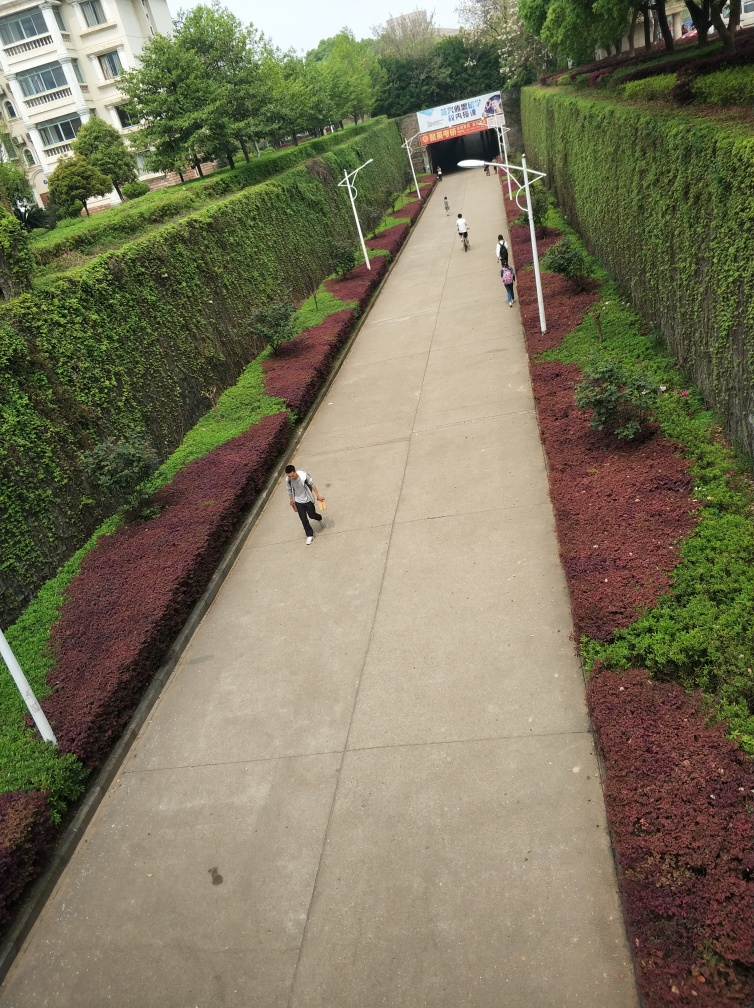What is the quality of the pedestrians in the image? The pedestrians appear at a significant distance from the camera, making distinct features harder to discern. However, they are recognizable as individuals going about their daily activities, with one person seemingly focused on their mobile phone. The image quality is sufficient to make out their actions and provides a sense of the environment they are in. 